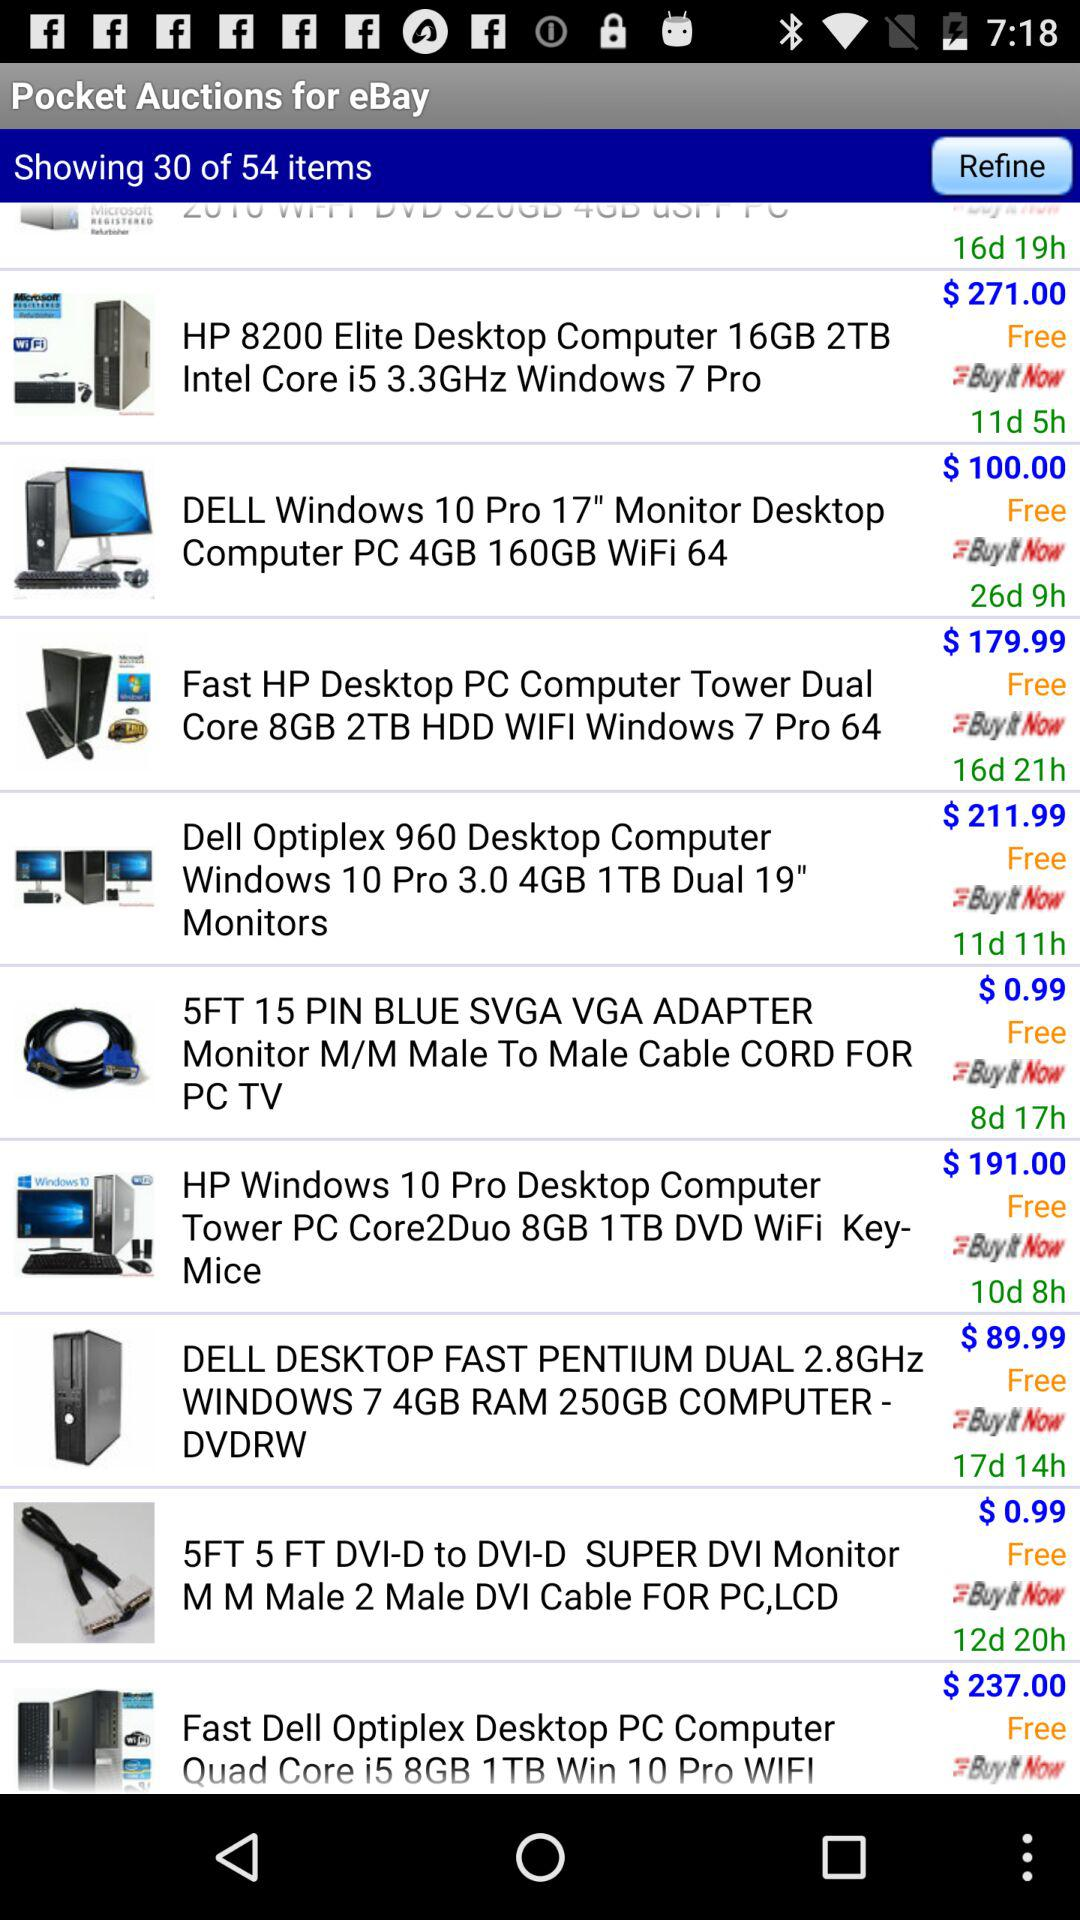How much time is left for the purchase of "Fast Dell Optiplex Desktop PC Computer Quad Core i5 8GB 1 TB Win 10 Pro WIFI"?
When the provided information is insufficient, respond with <no answer>. <no answer> 